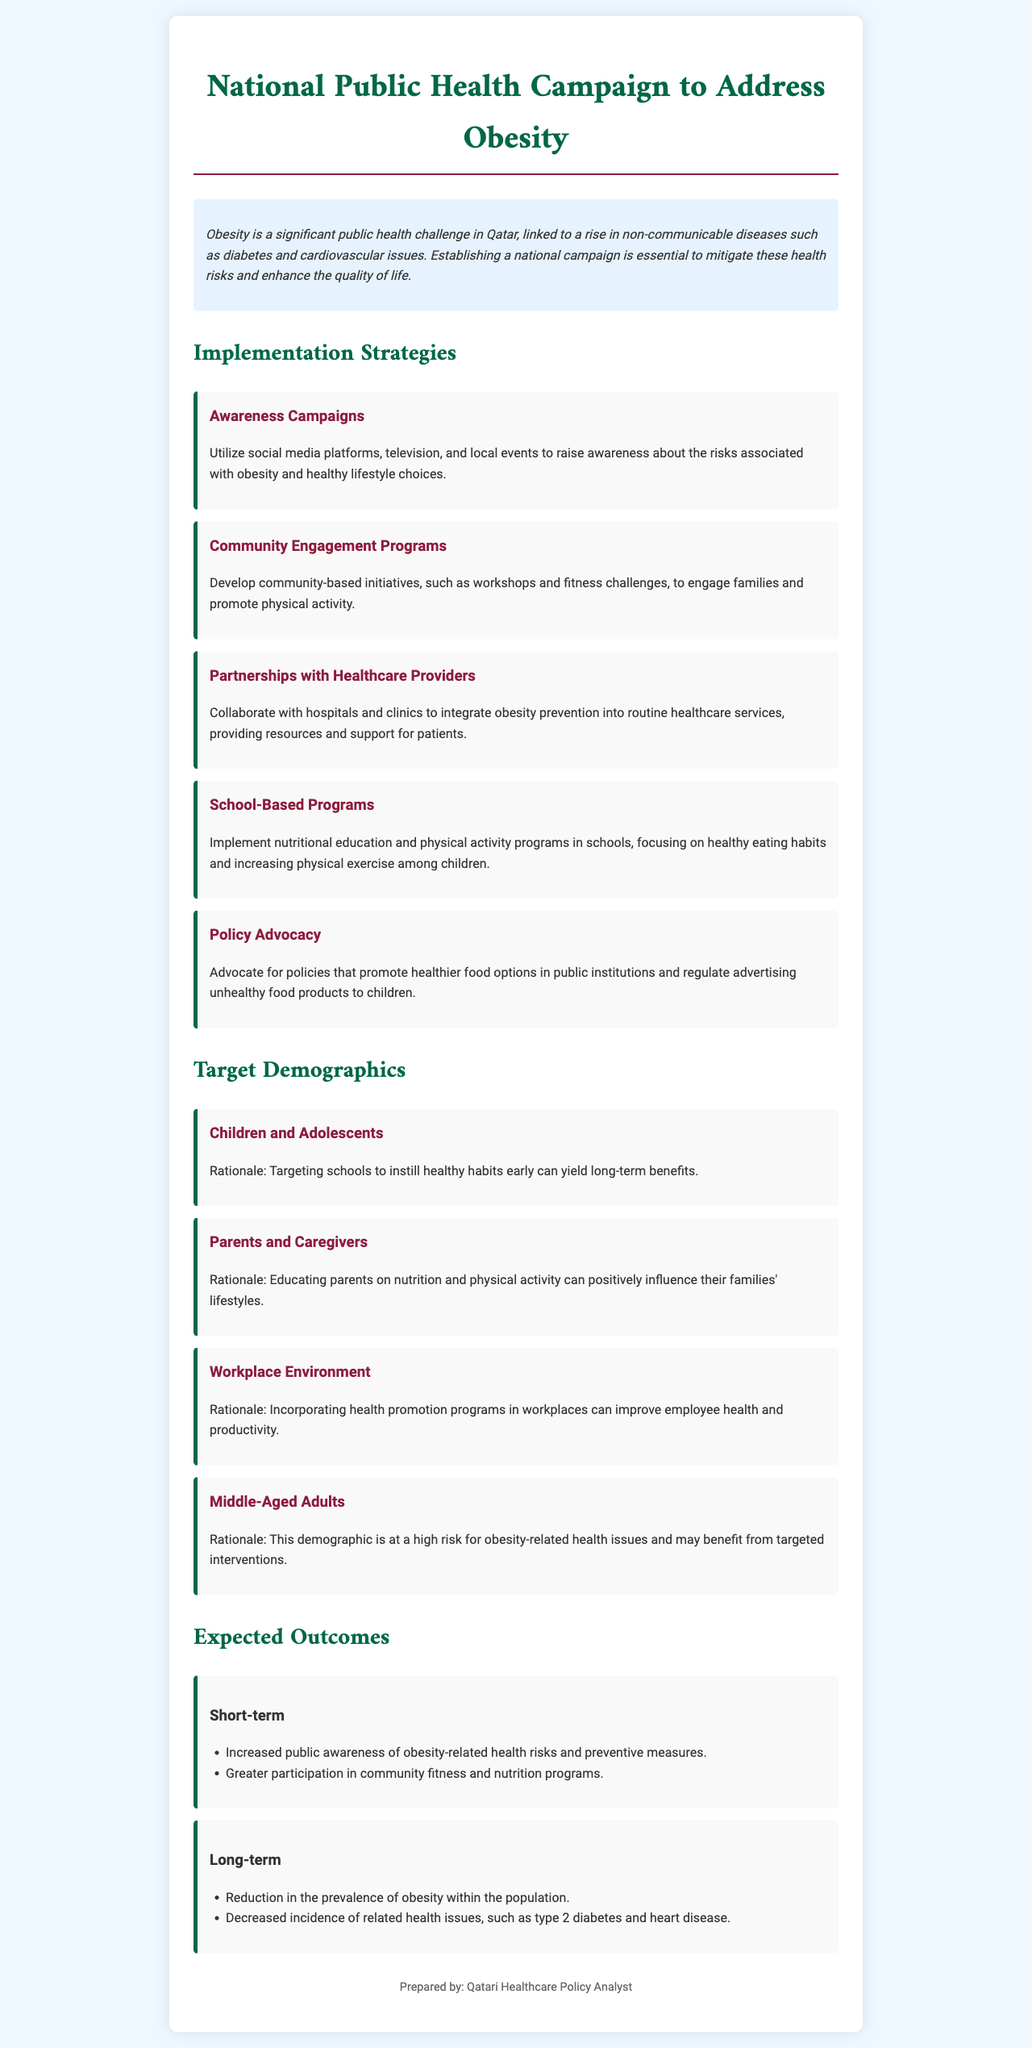What is the main public health challenge addressed in the proposal? The proposal addresses obesity as a significant public health challenge linked to non-communicable diseases.
Answer: Obesity What strategy involves collaborating with hospitals and clinics? The strategy that involves collaborating with hospitals is partnerships with healthcare providers.
Answer: Partnerships with Healthcare Providers Which demographic is targeted for nutritional education programs in schools? The demographic targeted for nutritional education programs in schools is children and adolescents.
Answer: Children and Adolescents What outcome is expected in the short-term regarding community participation? The expected short-term outcome is greater participation in community fitness and nutrition programs.
Answer: Greater participation What is the rationale for targeting middle-aged adults? Middle-aged adults are at a high risk for obesity-related health issues and may benefit from targeted interventions.
Answer: High risk for obesity-related health issues 